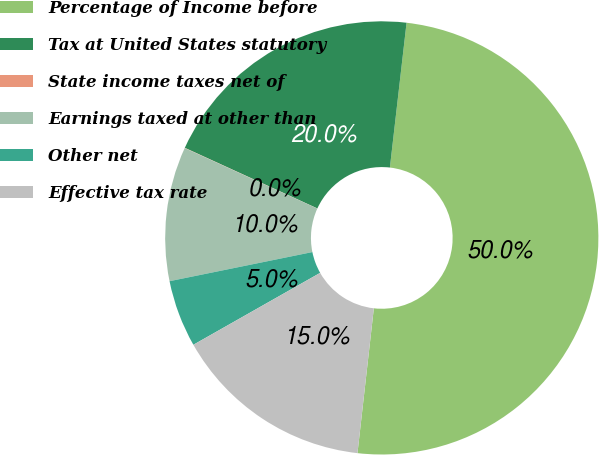Convert chart. <chart><loc_0><loc_0><loc_500><loc_500><pie_chart><fcel>Percentage of Income before<fcel>Tax at United States statutory<fcel>State income taxes net of<fcel>Earnings taxed at other than<fcel>Other net<fcel>Effective tax rate<nl><fcel>49.97%<fcel>20.0%<fcel>0.02%<fcel>10.01%<fcel>5.01%<fcel>15.0%<nl></chart> 